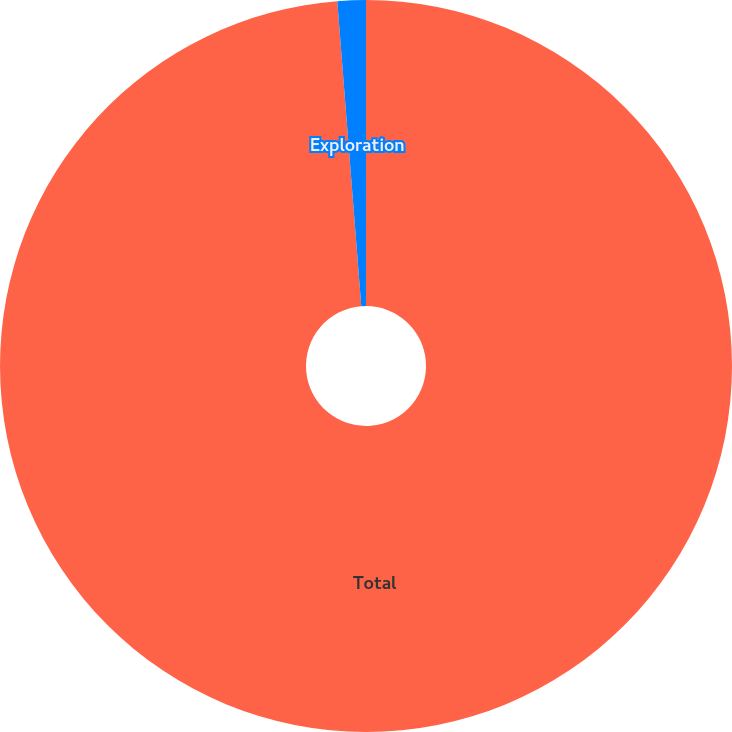<chart> <loc_0><loc_0><loc_500><loc_500><pie_chart><fcel>Total<fcel>Exploration<nl><fcel>98.75%<fcel>1.25%<nl></chart> 